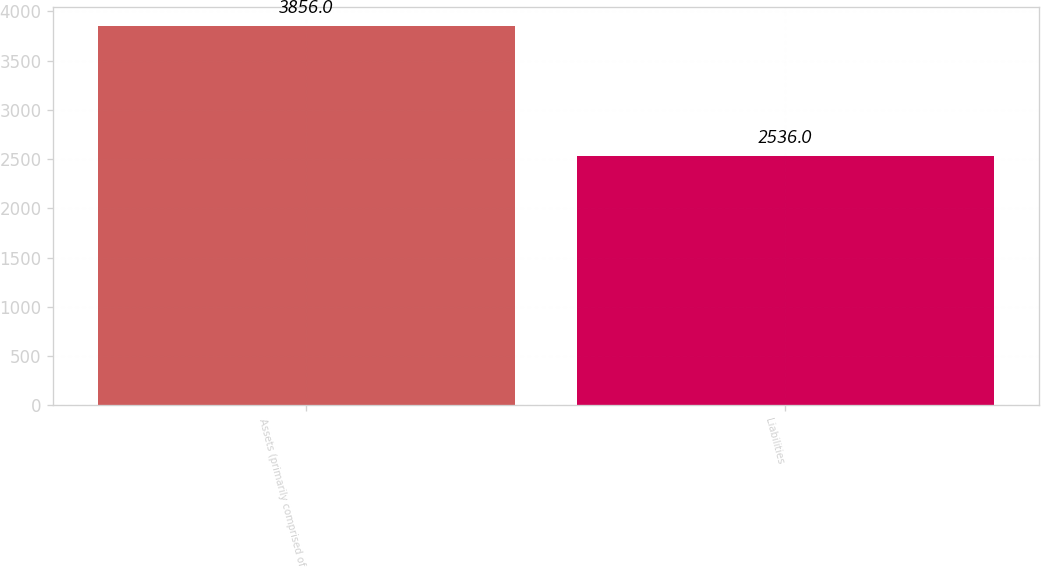Convert chart. <chart><loc_0><loc_0><loc_500><loc_500><bar_chart><fcel>Assets (primarily comprised of<fcel>Liabilities<nl><fcel>3856<fcel>2536<nl></chart> 